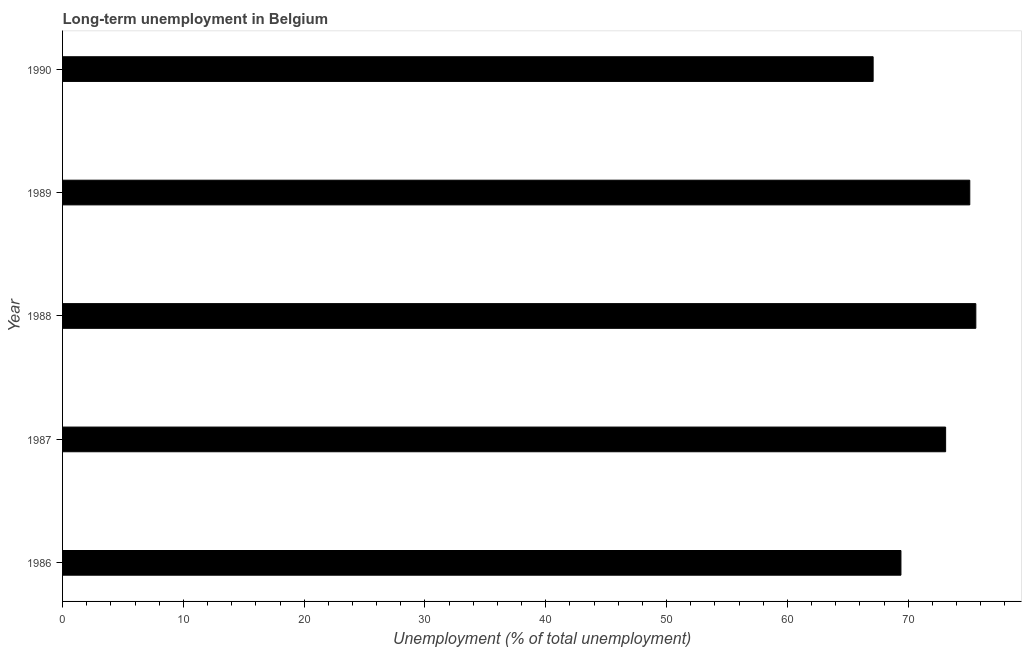Does the graph contain grids?
Your answer should be very brief. No. What is the title of the graph?
Offer a very short reply. Long-term unemployment in Belgium. What is the label or title of the X-axis?
Provide a succinct answer. Unemployment (% of total unemployment). What is the long-term unemployment in 1989?
Give a very brief answer. 75.1. Across all years, what is the maximum long-term unemployment?
Your answer should be compact. 75.6. Across all years, what is the minimum long-term unemployment?
Your response must be concise. 67.1. In which year was the long-term unemployment maximum?
Offer a very short reply. 1988. In which year was the long-term unemployment minimum?
Provide a succinct answer. 1990. What is the sum of the long-term unemployment?
Offer a terse response. 360.3. What is the difference between the long-term unemployment in 1986 and 1988?
Offer a terse response. -6.2. What is the average long-term unemployment per year?
Provide a short and direct response. 72.06. What is the median long-term unemployment?
Ensure brevity in your answer.  73.1. Do a majority of the years between 1990 and 1987 (inclusive) have long-term unemployment greater than 4 %?
Your response must be concise. Yes. What is the ratio of the long-term unemployment in 1986 to that in 1990?
Your answer should be compact. 1.03. Is the long-term unemployment in 1986 less than that in 1988?
Provide a succinct answer. Yes. Is the difference between the long-term unemployment in 1986 and 1990 greater than the difference between any two years?
Provide a succinct answer. No. What is the difference between the highest and the second highest long-term unemployment?
Offer a very short reply. 0.5. What is the difference between the highest and the lowest long-term unemployment?
Your response must be concise. 8.5. Are all the bars in the graph horizontal?
Your response must be concise. Yes. What is the difference between two consecutive major ticks on the X-axis?
Provide a short and direct response. 10. What is the Unemployment (% of total unemployment) in 1986?
Offer a very short reply. 69.4. What is the Unemployment (% of total unemployment) in 1987?
Your answer should be compact. 73.1. What is the Unemployment (% of total unemployment) in 1988?
Offer a terse response. 75.6. What is the Unemployment (% of total unemployment) in 1989?
Your answer should be compact. 75.1. What is the Unemployment (% of total unemployment) of 1990?
Offer a very short reply. 67.1. What is the difference between the Unemployment (% of total unemployment) in 1986 and 1987?
Keep it short and to the point. -3.7. What is the difference between the Unemployment (% of total unemployment) in 1986 and 1988?
Keep it short and to the point. -6.2. What is the difference between the Unemployment (% of total unemployment) in 1986 and 1990?
Provide a short and direct response. 2.3. What is the difference between the Unemployment (% of total unemployment) in 1987 and 1990?
Your answer should be compact. 6. What is the difference between the Unemployment (% of total unemployment) in 1988 and 1989?
Ensure brevity in your answer.  0.5. What is the difference between the Unemployment (% of total unemployment) in 1989 and 1990?
Ensure brevity in your answer.  8. What is the ratio of the Unemployment (% of total unemployment) in 1986 to that in 1987?
Make the answer very short. 0.95. What is the ratio of the Unemployment (% of total unemployment) in 1986 to that in 1988?
Provide a short and direct response. 0.92. What is the ratio of the Unemployment (% of total unemployment) in 1986 to that in 1989?
Your answer should be compact. 0.92. What is the ratio of the Unemployment (% of total unemployment) in 1986 to that in 1990?
Provide a short and direct response. 1.03. What is the ratio of the Unemployment (% of total unemployment) in 1987 to that in 1989?
Your response must be concise. 0.97. What is the ratio of the Unemployment (% of total unemployment) in 1987 to that in 1990?
Offer a terse response. 1.09. What is the ratio of the Unemployment (% of total unemployment) in 1988 to that in 1989?
Offer a terse response. 1.01. What is the ratio of the Unemployment (% of total unemployment) in 1988 to that in 1990?
Your answer should be very brief. 1.13. What is the ratio of the Unemployment (% of total unemployment) in 1989 to that in 1990?
Your answer should be very brief. 1.12. 